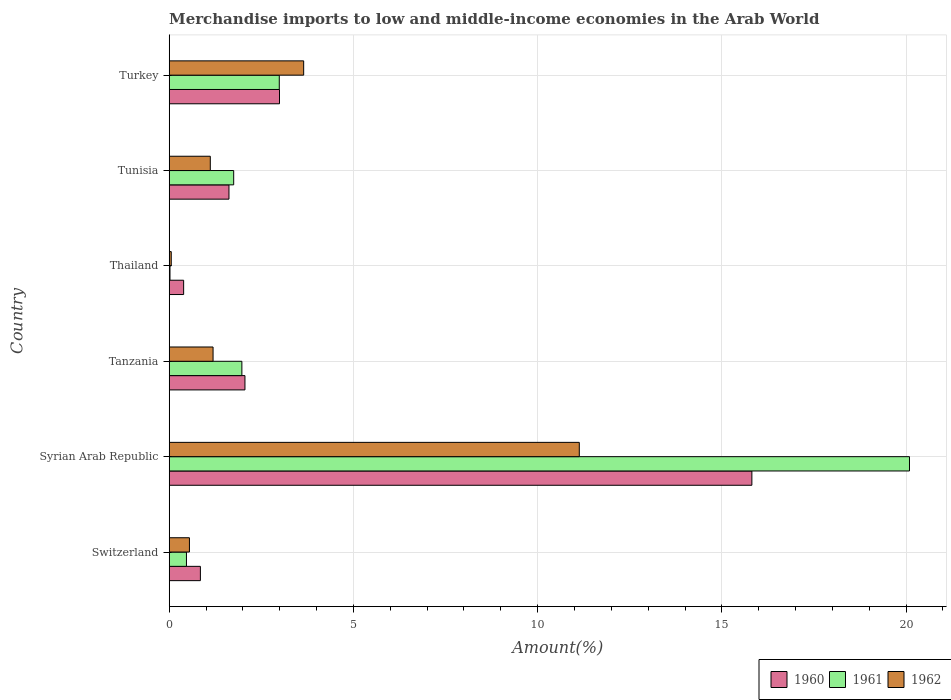How many groups of bars are there?
Ensure brevity in your answer.  6. Are the number of bars per tick equal to the number of legend labels?
Your answer should be compact. Yes. How many bars are there on the 6th tick from the top?
Make the answer very short. 3. How many bars are there on the 2nd tick from the bottom?
Your answer should be very brief. 3. What is the label of the 1st group of bars from the top?
Ensure brevity in your answer.  Turkey. What is the percentage of amount earned from merchandise imports in 1961 in Tanzania?
Your answer should be compact. 1.97. Across all countries, what is the maximum percentage of amount earned from merchandise imports in 1962?
Offer a very short reply. 11.13. Across all countries, what is the minimum percentage of amount earned from merchandise imports in 1961?
Your answer should be very brief. 0.02. In which country was the percentage of amount earned from merchandise imports in 1962 maximum?
Give a very brief answer. Syrian Arab Republic. In which country was the percentage of amount earned from merchandise imports in 1961 minimum?
Keep it short and to the point. Thailand. What is the total percentage of amount earned from merchandise imports in 1961 in the graph?
Give a very brief answer. 27.29. What is the difference between the percentage of amount earned from merchandise imports in 1960 in Syrian Arab Republic and that in Tunisia?
Ensure brevity in your answer.  14.19. What is the difference between the percentage of amount earned from merchandise imports in 1961 in Turkey and the percentage of amount earned from merchandise imports in 1962 in Syrian Arab Republic?
Keep it short and to the point. -8.14. What is the average percentage of amount earned from merchandise imports in 1961 per country?
Provide a short and direct response. 4.55. What is the difference between the percentage of amount earned from merchandise imports in 1962 and percentage of amount earned from merchandise imports in 1960 in Tanzania?
Offer a very short reply. -0.87. What is the ratio of the percentage of amount earned from merchandise imports in 1961 in Thailand to that in Turkey?
Offer a terse response. 0.01. Is the percentage of amount earned from merchandise imports in 1961 in Thailand less than that in Turkey?
Provide a short and direct response. Yes. What is the difference between the highest and the second highest percentage of amount earned from merchandise imports in 1960?
Offer a terse response. 12.82. What is the difference between the highest and the lowest percentage of amount earned from merchandise imports in 1962?
Offer a very short reply. 11.07. In how many countries, is the percentage of amount earned from merchandise imports in 1961 greater than the average percentage of amount earned from merchandise imports in 1961 taken over all countries?
Provide a succinct answer. 1. Is the sum of the percentage of amount earned from merchandise imports in 1961 in Syrian Arab Republic and Tanzania greater than the maximum percentage of amount earned from merchandise imports in 1962 across all countries?
Provide a succinct answer. Yes. What does the 3rd bar from the top in Tanzania represents?
Ensure brevity in your answer.  1960. Is it the case that in every country, the sum of the percentage of amount earned from merchandise imports in 1960 and percentage of amount earned from merchandise imports in 1961 is greater than the percentage of amount earned from merchandise imports in 1962?
Provide a succinct answer. Yes. Are all the bars in the graph horizontal?
Give a very brief answer. Yes. How many countries are there in the graph?
Your response must be concise. 6. Does the graph contain any zero values?
Ensure brevity in your answer.  No. Does the graph contain grids?
Provide a succinct answer. Yes. Where does the legend appear in the graph?
Offer a very short reply. Bottom right. How many legend labels are there?
Offer a very short reply. 3. How are the legend labels stacked?
Offer a terse response. Horizontal. What is the title of the graph?
Provide a short and direct response. Merchandise imports to low and middle-income economies in the Arab World. Does "2011" appear as one of the legend labels in the graph?
Your answer should be very brief. No. What is the label or title of the X-axis?
Keep it short and to the point. Amount(%). What is the Amount(%) of 1960 in Switzerland?
Provide a succinct answer. 0.85. What is the Amount(%) of 1961 in Switzerland?
Provide a short and direct response. 0.47. What is the Amount(%) of 1962 in Switzerland?
Provide a short and direct response. 0.55. What is the Amount(%) in 1960 in Syrian Arab Republic?
Provide a short and direct response. 15.81. What is the Amount(%) of 1961 in Syrian Arab Republic?
Provide a short and direct response. 20.09. What is the Amount(%) of 1962 in Syrian Arab Republic?
Your answer should be very brief. 11.13. What is the Amount(%) in 1960 in Tanzania?
Keep it short and to the point. 2.06. What is the Amount(%) in 1961 in Tanzania?
Your answer should be very brief. 1.97. What is the Amount(%) in 1962 in Tanzania?
Offer a terse response. 1.19. What is the Amount(%) in 1960 in Thailand?
Keep it short and to the point. 0.39. What is the Amount(%) of 1961 in Thailand?
Provide a succinct answer. 0.02. What is the Amount(%) in 1962 in Thailand?
Make the answer very short. 0.06. What is the Amount(%) in 1960 in Tunisia?
Make the answer very short. 1.62. What is the Amount(%) in 1961 in Tunisia?
Your answer should be compact. 1.75. What is the Amount(%) of 1962 in Tunisia?
Provide a short and direct response. 1.12. What is the Amount(%) of 1960 in Turkey?
Provide a short and direct response. 2.99. What is the Amount(%) of 1961 in Turkey?
Offer a terse response. 2.99. What is the Amount(%) in 1962 in Turkey?
Keep it short and to the point. 3.65. Across all countries, what is the maximum Amount(%) in 1960?
Your response must be concise. 15.81. Across all countries, what is the maximum Amount(%) of 1961?
Offer a very short reply. 20.09. Across all countries, what is the maximum Amount(%) in 1962?
Provide a short and direct response. 11.13. Across all countries, what is the minimum Amount(%) of 1960?
Offer a terse response. 0.39. Across all countries, what is the minimum Amount(%) in 1961?
Offer a very short reply. 0.02. Across all countries, what is the minimum Amount(%) in 1962?
Give a very brief answer. 0.06. What is the total Amount(%) in 1960 in the graph?
Give a very brief answer. 23.72. What is the total Amount(%) of 1961 in the graph?
Provide a short and direct response. 27.29. What is the total Amount(%) of 1962 in the graph?
Make the answer very short. 17.69. What is the difference between the Amount(%) of 1960 in Switzerland and that in Syrian Arab Republic?
Provide a short and direct response. -14.97. What is the difference between the Amount(%) in 1961 in Switzerland and that in Syrian Arab Republic?
Your answer should be very brief. -19.62. What is the difference between the Amount(%) in 1962 in Switzerland and that in Syrian Arab Republic?
Your answer should be compact. -10.58. What is the difference between the Amount(%) of 1960 in Switzerland and that in Tanzania?
Offer a terse response. -1.21. What is the difference between the Amount(%) in 1961 in Switzerland and that in Tanzania?
Provide a succinct answer. -1.5. What is the difference between the Amount(%) of 1962 in Switzerland and that in Tanzania?
Ensure brevity in your answer.  -0.64. What is the difference between the Amount(%) in 1960 in Switzerland and that in Thailand?
Provide a succinct answer. 0.45. What is the difference between the Amount(%) of 1961 in Switzerland and that in Thailand?
Make the answer very short. 0.45. What is the difference between the Amount(%) in 1962 in Switzerland and that in Thailand?
Your answer should be very brief. 0.49. What is the difference between the Amount(%) of 1960 in Switzerland and that in Tunisia?
Keep it short and to the point. -0.78. What is the difference between the Amount(%) in 1961 in Switzerland and that in Tunisia?
Make the answer very short. -1.28. What is the difference between the Amount(%) of 1962 in Switzerland and that in Tunisia?
Make the answer very short. -0.57. What is the difference between the Amount(%) of 1960 in Switzerland and that in Turkey?
Offer a very short reply. -2.15. What is the difference between the Amount(%) in 1961 in Switzerland and that in Turkey?
Give a very brief answer. -2.52. What is the difference between the Amount(%) in 1960 in Syrian Arab Republic and that in Tanzania?
Keep it short and to the point. 13.76. What is the difference between the Amount(%) in 1961 in Syrian Arab Republic and that in Tanzania?
Your response must be concise. 18.12. What is the difference between the Amount(%) in 1962 in Syrian Arab Republic and that in Tanzania?
Keep it short and to the point. 9.94. What is the difference between the Amount(%) in 1960 in Syrian Arab Republic and that in Thailand?
Provide a short and direct response. 15.42. What is the difference between the Amount(%) in 1961 in Syrian Arab Republic and that in Thailand?
Your answer should be compact. 20.07. What is the difference between the Amount(%) in 1962 in Syrian Arab Republic and that in Thailand?
Make the answer very short. 11.07. What is the difference between the Amount(%) of 1960 in Syrian Arab Republic and that in Tunisia?
Ensure brevity in your answer.  14.19. What is the difference between the Amount(%) in 1961 in Syrian Arab Republic and that in Tunisia?
Keep it short and to the point. 18.34. What is the difference between the Amount(%) in 1962 in Syrian Arab Republic and that in Tunisia?
Your answer should be very brief. 10.01. What is the difference between the Amount(%) of 1960 in Syrian Arab Republic and that in Turkey?
Your answer should be compact. 12.82. What is the difference between the Amount(%) in 1961 in Syrian Arab Republic and that in Turkey?
Offer a terse response. 17.1. What is the difference between the Amount(%) in 1962 in Syrian Arab Republic and that in Turkey?
Your answer should be very brief. 7.48. What is the difference between the Amount(%) in 1960 in Tanzania and that in Thailand?
Your answer should be compact. 1.66. What is the difference between the Amount(%) in 1961 in Tanzania and that in Thailand?
Offer a very short reply. 1.95. What is the difference between the Amount(%) of 1962 in Tanzania and that in Thailand?
Make the answer very short. 1.13. What is the difference between the Amount(%) in 1960 in Tanzania and that in Tunisia?
Keep it short and to the point. 0.43. What is the difference between the Amount(%) in 1961 in Tanzania and that in Tunisia?
Ensure brevity in your answer.  0.22. What is the difference between the Amount(%) in 1962 in Tanzania and that in Tunisia?
Keep it short and to the point. 0.08. What is the difference between the Amount(%) of 1960 in Tanzania and that in Turkey?
Your response must be concise. -0.94. What is the difference between the Amount(%) in 1961 in Tanzania and that in Turkey?
Give a very brief answer. -1.02. What is the difference between the Amount(%) of 1962 in Tanzania and that in Turkey?
Your answer should be very brief. -2.46. What is the difference between the Amount(%) in 1960 in Thailand and that in Tunisia?
Ensure brevity in your answer.  -1.23. What is the difference between the Amount(%) in 1961 in Thailand and that in Tunisia?
Make the answer very short. -1.73. What is the difference between the Amount(%) in 1962 in Thailand and that in Tunisia?
Your response must be concise. -1.06. What is the difference between the Amount(%) in 1960 in Thailand and that in Turkey?
Give a very brief answer. -2.6. What is the difference between the Amount(%) of 1961 in Thailand and that in Turkey?
Your response must be concise. -2.97. What is the difference between the Amount(%) in 1962 in Thailand and that in Turkey?
Your answer should be compact. -3.59. What is the difference between the Amount(%) of 1960 in Tunisia and that in Turkey?
Provide a short and direct response. -1.37. What is the difference between the Amount(%) of 1961 in Tunisia and that in Turkey?
Offer a terse response. -1.24. What is the difference between the Amount(%) in 1962 in Tunisia and that in Turkey?
Offer a very short reply. -2.53. What is the difference between the Amount(%) in 1960 in Switzerland and the Amount(%) in 1961 in Syrian Arab Republic?
Give a very brief answer. -19.25. What is the difference between the Amount(%) of 1960 in Switzerland and the Amount(%) of 1962 in Syrian Arab Republic?
Your response must be concise. -10.28. What is the difference between the Amount(%) of 1961 in Switzerland and the Amount(%) of 1962 in Syrian Arab Republic?
Ensure brevity in your answer.  -10.66. What is the difference between the Amount(%) in 1960 in Switzerland and the Amount(%) in 1961 in Tanzania?
Provide a short and direct response. -1.13. What is the difference between the Amount(%) in 1960 in Switzerland and the Amount(%) in 1962 in Tanzania?
Provide a succinct answer. -0.34. What is the difference between the Amount(%) in 1961 in Switzerland and the Amount(%) in 1962 in Tanzania?
Offer a terse response. -0.72. What is the difference between the Amount(%) in 1960 in Switzerland and the Amount(%) in 1961 in Thailand?
Your answer should be compact. 0.82. What is the difference between the Amount(%) of 1960 in Switzerland and the Amount(%) of 1962 in Thailand?
Offer a terse response. 0.79. What is the difference between the Amount(%) of 1961 in Switzerland and the Amount(%) of 1962 in Thailand?
Your answer should be very brief. 0.41. What is the difference between the Amount(%) of 1960 in Switzerland and the Amount(%) of 1961 in Tunisia?
Give a very brief answer. -0.9. What is the difference between the Amount(%) of 1960 in Switzerland and the Amount(%) of 1962 in Tunisia?
Give a very brief answer. -0.27. What is the difference between the Amount(%) of 1961 in Switzerland and the Amount(%) of 1962 in Tunisia?
Provide a succinct answer. -0.65. What is the difference between the Amount(%) in 1960 in Switzerland and the Amount(%) in 1961 in Turkey?
Keep it short and to the point. -2.14. What is the difference between the Amount(%) in 1960 in Switzerland and the Amount(%) in 1962 in Turkey?
Your response must be concise. -2.8. What is the difference between the Amount(%) in 1961 in Switzerland and the Amount(%) in 1962 in Turkey?
Ensure brevity in your answer.  -3.18. What is the difference between the Amount(%) of 1960 in Syrian Arab Republic and the Amount(%) of 1961 in Tanzania?
Your answer should be compact. 13.84. What is the difference between the Amount(%) of 1960 in Syrian Arab Republic and the Amount(%) of 1962 in Tanzania?
Give a very brief answer. 14.62. What is the difference between the Amount(%) in 1961 in Syrian Arab Republic and the Amount(%) in 1962 in Tanzania?
Provide a short and direct response. 18.9. What is the difference between the Amount(%) of 1960 in Syrian Arab Republic and the Amount(%) of 1961 in Thailand?
Your answer should be very brief. 15.79. What is the difference between the Amount(%) in 1960 in Syrian Arab Republic and the Amount(%) in 1962 in Thailand?
Provide a short and direct response. 15.76. What is the difference between the Amount(%) in 1961 in Syrian Arab Republic and the Amount(%) in 1962 in Thailand?
Make the answer very short. 20.04. What is the difference between the Amount(%) in 1960 in Syrian Arab Republic and the Amount(%) in 1961 in Tunisia?
Your answer should be very brief. 14.06. What is the difference between the Amount(%) in 1960 in Syrian Arab Republic and the Amount(%) in 1962 in Tunisia?
Provide a succinct answer. 14.7. What is the difference between the Amount(%) in 1961 in Syrian Arab Republic and the Amount(%) in 1962 in Tunisia?
Your answer should be very brief. 18.98. What is the difference between the Amount(%) of 1960 in Syrian Arab Republic and the Amount(%) of 1961 in Turkey?
Give a very brief answer. 12.83. What is the difference between the Amount(%) of 1960 in Syrian Arab Republic and the Amount(%) of 1962 in Turkey?
Your answer should be compact. 12.16. What is the difference between the Amount(%) in 1961 in Syrian Arab Republic and the Amount(%) in 1962 in Turkey?
Your answer should be compact. 16.44. What is the difference between the Amount(%) in 1960 in Tanzania and the Amount(%) in 1961 in Thailand?
Make the answer very short. 2.03. What is the difference between the Amount(%) of 1960 in Tanzania and the Amount(%) of 1962 in Thailand?
Your answer should be very brief. 2. What is the difference between the Amount(%) in 1961 in Tanzania and the Amount(%) in 1962 in Thailand?
Give a very brief answer. 1.92. What is the difference between the Amount(%) in 1960 in Tanzania and the Amount(%) in 1961 in Tunisia?
Your answer should be very brief. 0.31. What is the difference between the Amount(%) in 1960 in Tanzania and the Amount(%) in 1962 in Tunisia?
Ensure brevity in your answer.  0.94. What is the difference between the Amount(%) of 1961 in Tanzania and the Amount(%) of 1962 in Tunisia?
Your answer should be compact. 0.86. What is the difference between the Amount(%) of 1960 in Tanzania and the Amount(%) of 1961 in Turkey?
Give a very brief answer. -0.93. What is the difference between the Amount(%) of 1960 in Tanzania and the Amount(%) of 1962 in Turkey?
Make the answer very short. -1.59. What is the difference between the Amount(%) in 1961 in Tanzania and the Amount(%) in 1962 in Turkey?
Provide a succinct answer. -1.68. What is the difference between the Amount(%) of 1960 in Thailand and the Amount(%) of 1961 in Tunisia?
Make the answer very short. -1.36. What is the difference between the Amount(%) of 1960 in Thailand and the Amount(%) of 1962 in Tunisia?
Ensure brevity in your answer.  -0.72. What is the difference between the Amount(%) of 1961 in Thailand and the Amount(%) of 1962 in Tunisia?
Give a very brief answer. -1.09. What is the difference between the Amount(%) of 1960 in Thailand and the Amount(%) of 1961 in Turkey?
Your answer should be compact. -2.6. What is the difference between the Amount(%) in 1960 in Thailand and the Amount(%) in 1962 in Turkey?
Make the answer very short. -3.26. What is the difference between the Amount(%) in 1961 in Thailand and the Amount(%) in 1962 in Turkey?
Your response must be concise. -3.63. What is the difference between the Amount(%) in 1960 in Tunisia and the Amount(%) in 1961 in Turkey?
Your answer should be compact. -1.37. What is the difference between the Amount(%) in 1960 in Tunisia and the Amount(%) in 1962 in Turkey?
Offer a very short reply. -2.03. What is the difference between the Amount(%) of 1961 in Tunisia and the Amount(%) of 1962 in Turkey?
Your response must be concise. -1.9. What is the average Amount(%) of 1960 per country?
Give a very brief answer. 3.95. What is the average Amount(%) of 1961 per country?
Give a very brief answer. 4.55. What is the average Amount(%) in 1962 per country?
Provide a succinct answer. 2.95. What is the difference between the Amount(%) in 1960 and Amount(%) in 1961 in Switzerland?
Give a very brief answer. 0.38. What is the difference between the Amount(%) in 1960 and Amount(%) in 1962 in Switzerland?
Make the answer very short. 0.3. What is the difference between the Amount(%) in 1961 and Amount(%) in 1962 in Switzerland?
Make the answer very short. -0.08. What is the difference between the Amount(%) in 1960 and Amount(%) in 1961 in Syrian Arab Republic?
Your answer should be very brief. -4.28. What is the difference between the Amount(%) in 1960 and Amount(%) in 1962 in Syrian Arab Republic?
Your answer should be compact. 4.68. What is the difference between the Amount(%) in 1961 and Amount(%) in 1962 in Syrian Arab Republic?
Provide a short and direct response. 8.96. What is the difference between the Amount(%) in 1960 and Amount(%) in 1961 in Tanzania?
Offer a terse response. 0.08. What is the difference between the Amount(%) of 1960 and Amount(%) of 1962 in Tanzania?
Give a very brief answer. 0.87. What is the difference between the Amount(%) in 1961 and Amount(%) in 1962 in Tanzania?
Offer a very short reply. 0.78. What is the difference between the Amount(%) in 1960 and Amount(%) in 1961 in Thailand?
Ensure brevity in your answer.  0.37. What is the difference between the Amount(%) in 1960 and Amount(%) in 1962 in Thailand?
Your answer should be compact. 0.34. What is the difference between the Amount(%) of 1961 and Amount(%) of 1962 in Thailand?
Provide a succinct answer. -0.03. What is the difference between the Amount(%) in 1960 and Amount(%) in 1961 in Tunisia?
Your response must be concise. -0.13. What is the difference between the Amount(%) of 1960 and Amount(%) of 1962 in Tunisia?
Ensure brevity in your answer.  0.51. What is the difference between the Amount(%) of 1961 and Amount(%) of 1962 in Tunisia?
Your answer should be very brief. 0.64. What is the difference between the Amount(%) in 1960 and Amount(%) in 1961 in Turkey?
Provide a succinct answer. 0.01. What is the difference between the Amount(%) of 1960 and Amount(%) of 1962 in Turkey?
Make the answer very short. -0.66. What is the difference between the Amount(%) of 1961 and Amount(%) of 1962 in Turkey?
Your answer should be compact. -0.66. What is the ratio of the Amount(%) of 1960 in Switzerland to that in Syrian Arab Republic?
Your response must be concise. 0.05. What is the ratio of the Amount(%) of 1961 in Switzerland to that in Syrian Arab Republic?
Your answer should be compact. 0.02. What is the ratio of the Amount(%) of 1962 in Switzerland to that in Syrian Arab Republic?
Provide a short and direct response. 0.05. What is the ratio of the Amount(%) in 1960 in Switzerland to that in Tanzania?
Make the answer very short. 0.41. What is the ratio of the Amount(%) of 1961 in Switzerland to that in Tanzania?
Offer a terse response. 0.24. What is the ratio of the Amount(%) of 1962 in Switzerland to that in Tanzania?
Provide a short and direct response. 0.46. What is the ratio of the Amount(%) in 1960 in Switzerland to that in Thailand?
Make the answer very short. 2.16. What is the ratio of the Amount(%) in 1961 in Switzerland to that in Thailand?
Provide a short and direct response. 21.93. What is the ratio of the Amount(%) of 1962 in Switzerland to that in Thailand?
Your response must be concise. 9.89. What is the ratio of the Amount(%) of 1960 in Switzerland to that in Tunisia?
Provide a succinct answer. 0.52. What is the ratio of the Amount(%) in 1961 in Switzerland to that in Tunisia?
Provide a short and direct response. 0.27. What is the ratio of the Amount(%) in 1962 in Switzerland to that in Tunisia?
Offer a terse response. 0.49. What is the ratio of the Amount(%) in 1960 in Switzerland to that in Turkey?
Your answer should be compact. 0.28. What is the ratio of the Amount(%) of 1961 in Switzerland to that in Turkey?
Make the answer very short. 0.16. What is the ratio of the Amount(%) in 1962 in Switzerland to that in Turkey?
Your response must be concise. 0.15. What is the ratio of the Amount(%) of 1960 in Syrian Arab Republic to that in Tanzania?
Provide a short and direct response. 7.69. What is the ratio of the Amount(%) in 1961 in Syrian Arab Republic to that in Tanzania?
Provide a succinct answer. 10.19. What is the ratio of the Amount(%) in 1962 in Syrian Arab Republic to that in Tanzania?
Keep it short and to the point. 9.35. What is the ratio of the Amount(%) of 1960 in Syrian Arab Republic to that in Thailand?
Your response must be concise. 40.37. What is the ratio of the Amount(%) of 1961 in Syrian Arab Republic to that in Thailand?
Offer a terse response. 941.08. What is the ratio of the Amount(%) in 1962 in Syrian Arab Republic to that in Thailand?
Your answer should be compact. 200.38. What is the ratio of the Amount(%) of 1960 in Syrian Arab Republic to that in Tunisia?
Offer a terse response. 9.75. What is the ratio of the Amount(%) in 1961 in Syrian Arab Republic to that in Tunisia?
Provide a succinct answer. 11.48. What is the ratio of the Amount(%) in 1962 in Syrian Arab Republic to that in Tunisia?
Make the answer very short. 9.98. What is the ratio of the Amount(%) in 1960 in Syrian Arab Republic to that in Turkey?
Your answer should be very brief. 5.28. What is the ratio of the Amount(%) in 1961 in Syrian Arab Republic to that in Turkey?
Provide a short and direct response. 6.73. What is the ratio of the Amount(%) of 1962 in Syrian Arab Republic to that in Turkey?
Your answer should be compact. 3.05. What is the ratio of the Amount(%) in 1960 in Tanzania to that in Thailand?
Provide a succinct answer. 5.25. What is the ratio of the Amount(%) in 1961 in Tanzania to that in Thailand?
Offer a very short reply. 92.38. What is the ratio of the Amount(%) in 1962 in Tanzania to that in Thailand?
Provide a short and direct response. 21.43. What is the ratio of the Amount(%) of 1960 in Tanzania to that in Tunisia?
Make the answer very short. 1.27. What is the ratio of the Amount(%) of 1961 in Tanzania to that in Tunisia?
Your answer should be very brief. 1.13. What is the ratio of the Amount(%) of 1962 in Tanzania to that in Tunisia?
Offer a very short reply. 1.07. What is the ratio of the Amount(%) of 1960 in Tanzania to that in Turkey?
Provide a succinct answer. 0.69. What is the ratio of the Amount(%) in 1961 in Tanzania to that in Turkey?
Keep it short and to the point. 0.66. What is the ratio of the Amount(%) in 1962 in Tanzania to that in Turkey?
Provide a short and direct response. 0.33. What is the ratio of the Amount(%) of 1960 in Thailand to that in Tunisia?
Offer a very short reply. 0.24. What is the ratio of the Amount(%) of 1961 in Thailand to that in Tunisia?
Offer a terse response. 0.01. What is the ratio of the Amount(%) in 1962 in Thailand to that in Tunisia?
Provide a short and direct response. 0.05. What is the ratio of the Amount(%) in 1960 in Thailand to that in Turkey?
Ensure brevity in your answer.  0.13. What is the ratio of the Amount(%) of 1961 in Thailand to that in Turkey?
Provide a short and direct response. 0.01. What is the ratio of the Amount(%) in 1962 in Thailand to that in Turkey?
Offer a very short reply. 0.02. What is the ratio of the Amount(%) in 1960 in Tunisia to that in Turkey?
Ensure brevity in your answer.  0.54. What is the ratio of the Amount(%) in 1961 in Tunisia to that in Turkey?
Ensure brevity in your answer.  0.59. What is the ratio of the Amount(%) in 1962 in Tunisia to that in Turkey?
Make the answer very short. 0.31. What is the difference between the highest and the second highest Amount(%) of 1960?
Offer a very short reply. 12.82. What is the difference between the highest and the second highest Amount(%) of 1961?
Ensure brevity in your answer.  17.1. What is the difference between the highest and the second highest Amount(%) of 1962?
Provide a succinct answer. 7.48. What is the difference between the highest and the lowest Amount(%) of 1960?
Your answer should be compact. 15.42. What is the difference between the highest and the lowest Amount(%) of 1961?
Your answer should be compact. 20.07. What is the difference between the highest and the lowest Amount(%) in 1962?
Make the answer very short. 11.07. 